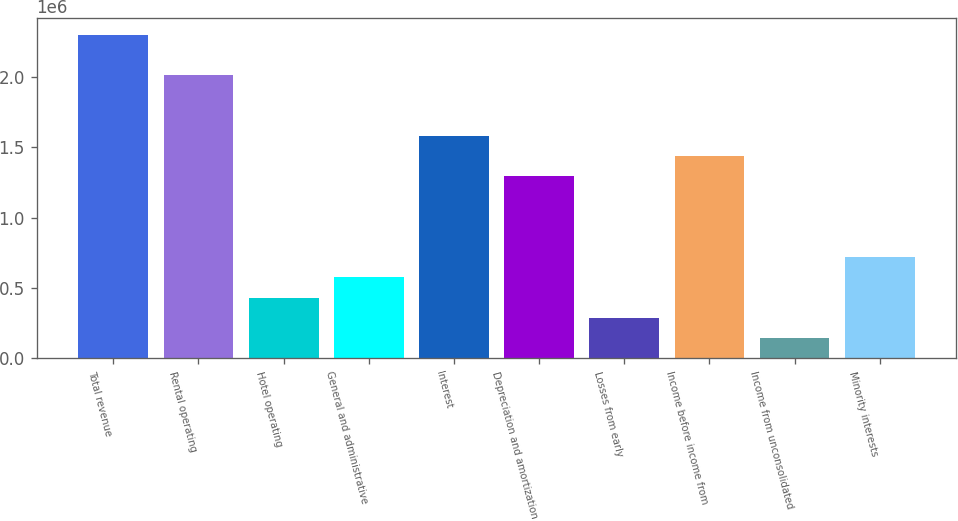Convert chart. <chart><loc_0><loc_0><loc_500><loc_500><bar_chart><fcel>Total revenue<fcel>Rental operating<fcel>Hotel operating<fcel>General and administrative<fcel>Interest<fcel>Depreciation and amortization<fcel>Losses from early<fcel>Income before income from<fcel>Income from unconsolidated<fcel>Minority interests<nl><fcel>2.30021e+06<fcel>2.01269e+06<fcel>431293<fcel>575056<fcel>1.5814e+06<fcel>1.29387e+06<fcel>287530<fcel>1.43764e+06<fcel>143767<fcel>718819<nl></chart> 